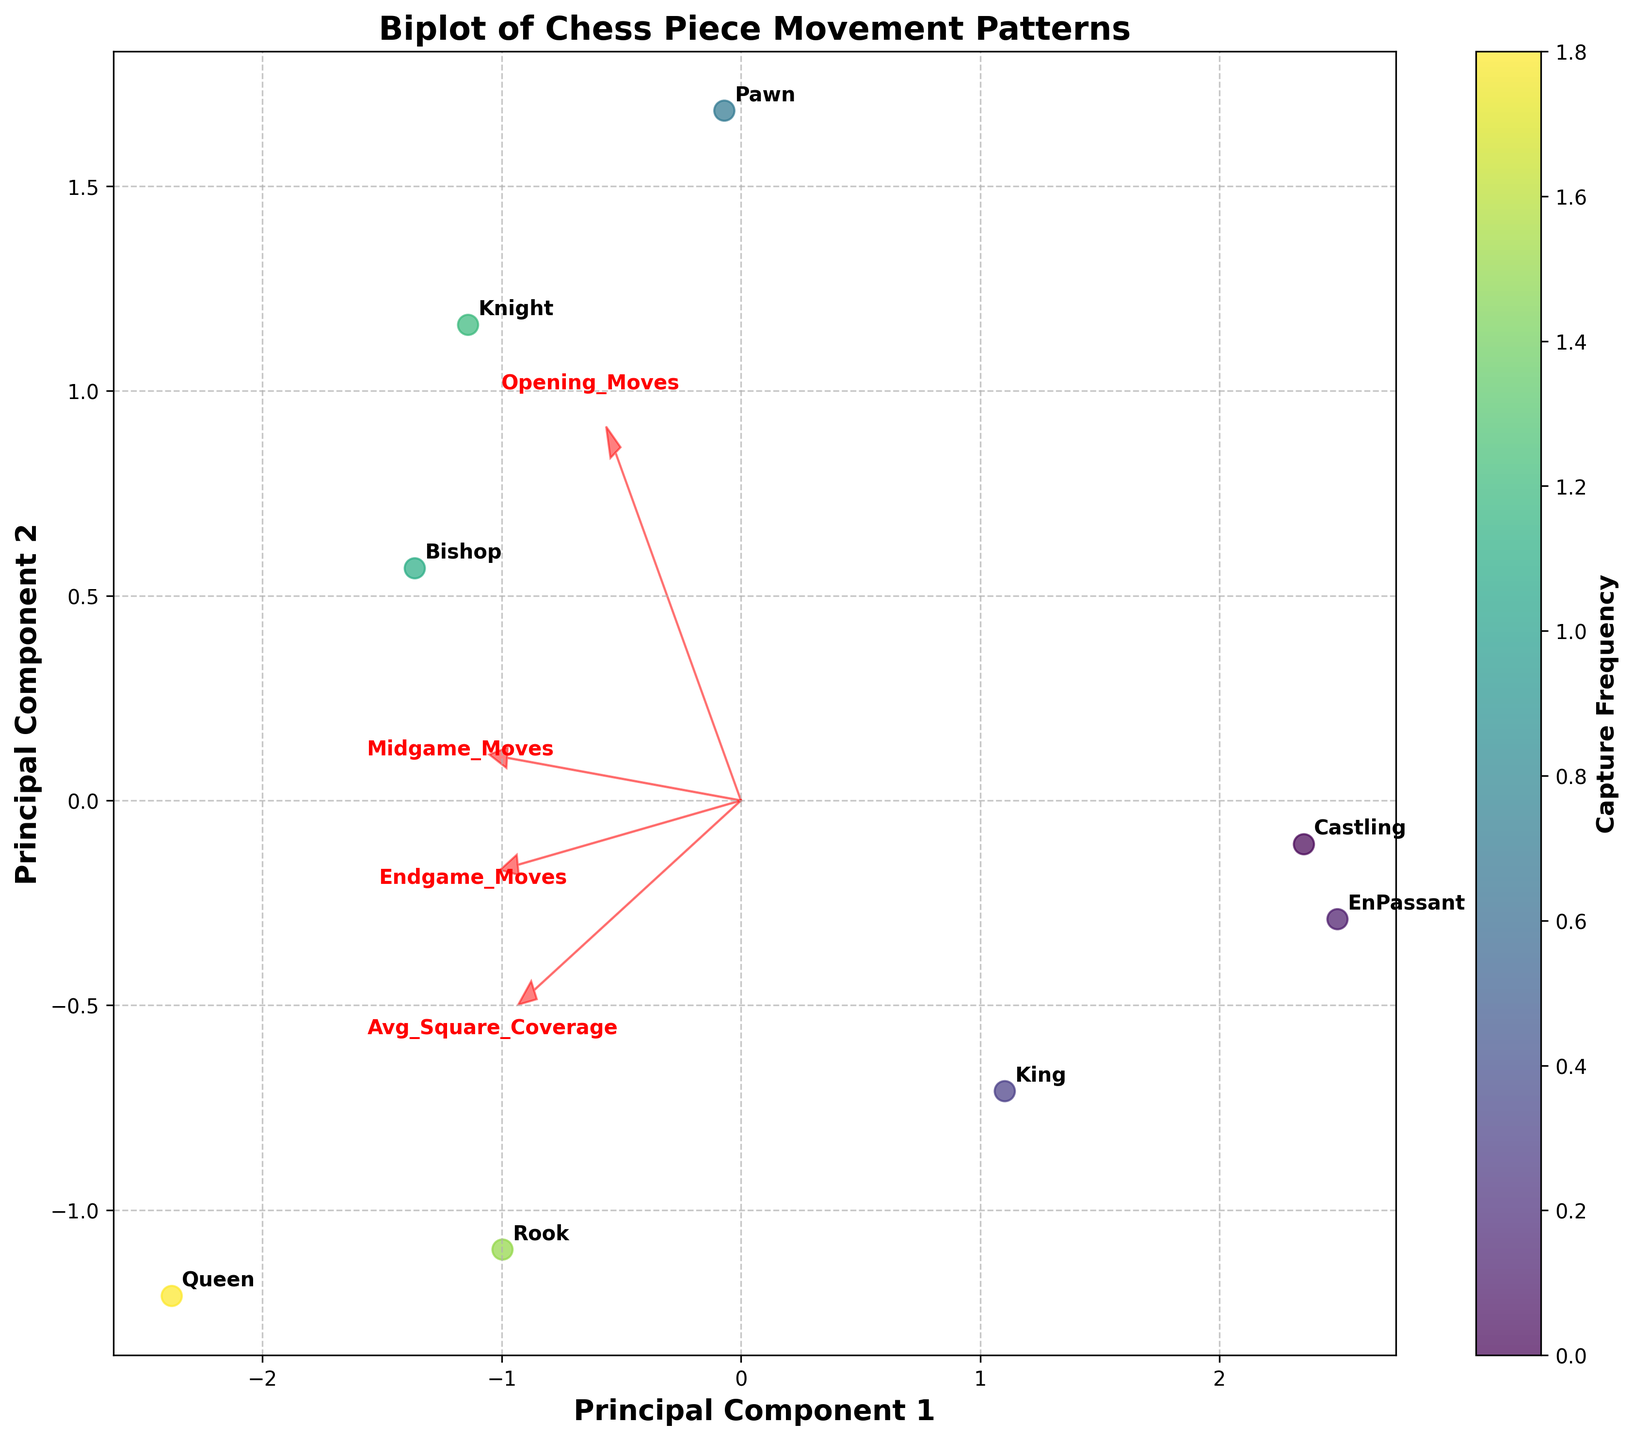what is the title of the figure? The title is placed prominently at the top of the figure and it reads "Biplot of Chess Piece Movement Patterns".
Answer: Biplot of Chess Piece Movement Patterns how many types of chess pieces are represented in the plot? There are labels next to each data point in the scatter plot indicating the different types of chess pieces. By counting these labels, we can see there are 8 types of pieces shown.
Answer: 8 which chess piece has the highest capture frequency? Capture frequency is represented by the color scale (color bar). The Queen is situated at the extreme high end of the scale corresponding to the highest value on the color bar.
Answer: Queen which feature has the largest arrow in the plot? The length of the arrows represents the feature loadings. The longest arrow is for "Avg_Square_Coverage", indicating it has the largest contribution.
Answer: Avg_Square_Coverage how do the movement patterns of knights in the midgame compare to those of rooks in the endgame? Rooks in the endgame move more frequently than Knights in the midgame. By following the labels and comparing their positions visually, Rooks in the endgame exhibit higher principal component contributions on the axes used in the plot.
Answer: Rooks in the endgame move more frequently which two features are most correlated based on their arrow directions? Features with arrows pointing in similar directions imply strong correlation. "Midgame_Moves" and "Endgame_Moves" have arrows pointing in very similar directions, suggesting a high correlation.
Answer: Midgame_Moves and Endgame_Moves which principal component contributes more to the variance in the direction of pawn movement in the opening? Principal Component 1 seems to contribute more to Pawn's opening moves as Pawn's position in the plot is more aligned along the x-axis (Principal Component 1).
Answer: Principal Component 1 do any chess pieces have similar movement patterns across all game stages based on their positions on the plot? Observing the clustering of data points, Bishops and Knights are positioned relatively closer together, suggesting that they have similar movement patterns across opening, middle, and end game stages.
Answer: Bishops and Knights what is the average square coverage for pawns? The figure has an arrow labeled "Avg_Square_Coverage", and by following this direction to the Pawn's data point, we see Pawns have an average square coverage indicated on the axis. However, for accuracy, refer to the data provided: 3.2.
Answer: 3.2 